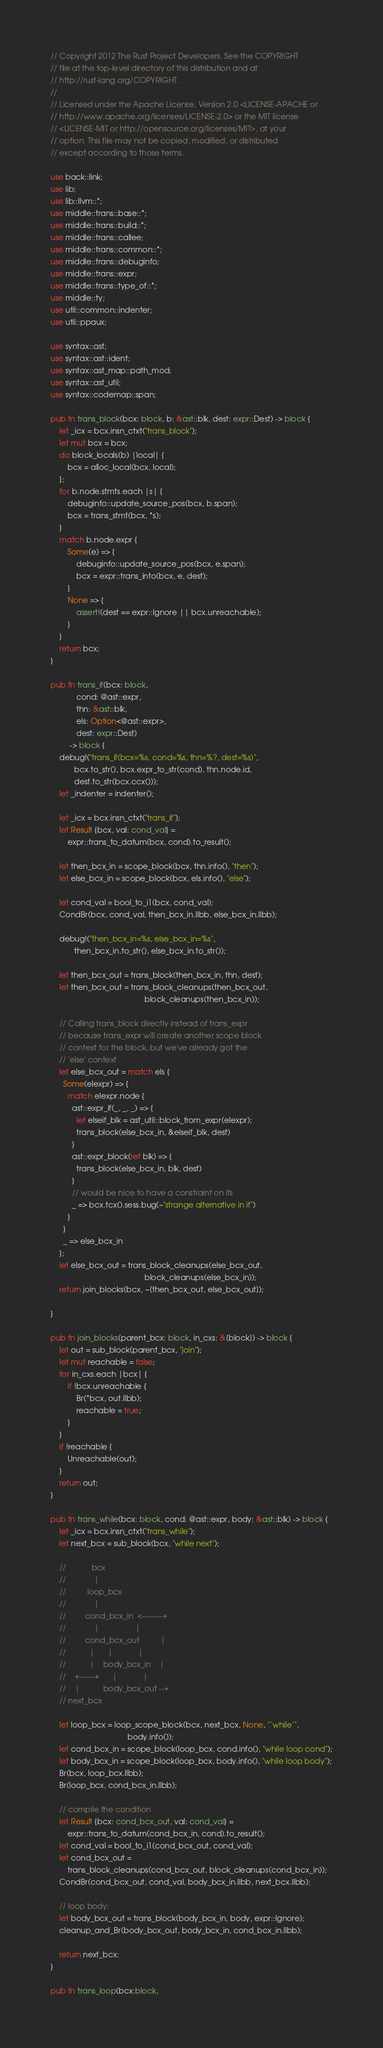<code> <loc_0><loc_0><loc_500><loc_500><_Rust_>// Copyright 2012 The Rust Project Developers. See the COPYRIGHT
// file at the top-level directory of this distribution and at
// http://rust-lang.org/COPYRIGHT.
//
// Licensed under the Apache License, Version 2.0 <LICENSE-APACHE or
// http://www.apache.org/licenses/LICENSE-2.0> or the MIT license
// <LICENSE-MIT or http://opensource.org/licenses/MIT>, at your
// option. This file may not be copied, modified, or distributed
// except according to those terms.

use back::link;
use lib;
use lib::llvm::*;
use middle::trans::base::*;
use middle::trans::build::*;
use middle::trans::callee;
use middle::trans::common::*;
use middle::trans::debuginfo;
use middle::trans::expr;
use middle::trans::type_of::*;
use middle::ty;
use util::common::indenter;
use util::ppaux;

use syntax::ast;
use syntax::ast::ident;
use syntax::ast_map::path_mod;
use syntax::ast_util;
use syntax::codemap::span;

pub fn trans_block(bcx: block, b: &ast::blk, dest: expr::Dest) -> block {
    let _icx = bcx.insn_ctxt("trans_block");
    let mut bcx = bcx;
    do block_locals(b) |local| {
        bcx = alloc_local(bcx, local);
    };
    for b.node.stmts.each |s| {
        debuginfo::update_source_pos(bcx, b.span);
        bcx = trans_stmt(bcx, *s);
    }
    match b.node.expr {
        Some(e) => {
            debuginfo::update_source_pos(bcx, e.span);
            bcx = expr::trans_into(bcx, e, dest);
        }
        None => {
            assert!(dest == expr::Ignore || bcx.unreachable);
        }
    }
    return bcx;
}

pub fn trans_if(bcx: block,
            cond: @ast::expr,
            thn: &ast::blk,
            els: Option<@ast::expr>,
            dest: expr::Dest)
         -> block {
    debug!("trans_if(bcx=%s, cond=%s, thn=%?, dest=%s)",
           bcx.to_str(), bcx.expr_to_str(cond), thn.node.id,
           dest.to_str(bcx.ccx()));
    let _indenter = indenter();

    let _icx = bcx.insn_ctxt("trans_if");
    let Result {bcx, val: cond_val} =
        expr::trans_to_datum(bcx, cond).to_result();

    let then_bcx_in = scope_block(bcx, thn.info(), "then");
    let else_bcx_in = scope_block(bcx, els.info(), "else");

    let cond_val = bool_to_i1(bcx, cond_val);
    CondBr(bcx, cond_val, then_bcx_in.llbb, else_bcx_in.llbb);

    debug!("then_bcx_in=%s, else_bcx_in=%s",
           then_bcx_in.to_str(), else_bcx_in.to_str());

    let then_bcx_out = trans_block(then_bcx_in, thn, dest);
    let then_bcx_out = trans_block_cleanups(then_bcx_out,
                                            block_cleanups(then_bcx_in));

    // Calling trans_block directly instead of trans_expr
    // because trans_expr will create another scope block
    // context for the block, but we've already got the
    // 'else' context
    let else_bcx_out = match els {
      Some(elexpr) => {
        match elexpr.node {
          ast::expr_if(_, _, _) => {
            let elseif_blk = ast_util::block_from_expr(elexpr);
            trans_block(else_bcx_in, &elseif_blk, dest)
          }
          ast::expr_block(ref blk) => {
            trans_block(else_bcx_in, blk, dest)
          }
          // would be nice to have a constraint on ifs
          _ => bcx.tcx().sess.bug(~"strange alternative in if")
        }
      }
      _ => else_bcx_in
    };
    let else_bcx_out = trans_block_cleanups(else_bcx_out,
                                            block_cleanups(else_bcx_in));
    return join_blocks(bcx, ~[then_bcx_out, else_bcx_out]);

}

pub fn join_blocks(parent_bcx: block, in_cxs: &[block]) -> block {
    let out = sub_block(parent_bcx, "join");
    let mut reachable = false;
    for in_cxs.each |bcx| {
        if !bcx.unreachable {
            Br(*bcx, out.llbb);
            reachable = true;
        }
    }
    if !reachable {
        Unreachable(out);
    }
    return out;
}

pub fn trans_while(bcx: block, cond: @ast::expr, body: &ast::blk) -> block {
    let _icx = bcx.insn_ctxt("trans_while");
    let next_bcx = sub_block(bcx, "while next");

    //            bcx
    //             |
    //          loop_bcx
    //             |
    //         cond_bcx_in  <--------+
    //             |                 |
    //         cond_bcx_out          |
    //           |      |            |
    //           |    body_bcx_in    |
    //    +------+      |            |
    //    |           body_bcx_out --+
    // next_bcx

    let loop_bcx = loop_scope_block(bcx, next_bcx, None, "`while`",
                                    body.info());
    let cond_bcx_in = scope_block(loop_bcx, cond.info(), "while loop cond");
    let body_bcx_in = scope_block(loop_bcx, body.info(), "while loop body");
    Br(bcx, loop_bcx.llbb);
    Br(loop_bcx, cond_bcx_in.llbb);

    // compile the condition
    let Result {bcx: cond_bcx_out, val: cond_val} =
        expr::trans_to_datum(cond_bcx_in, cond).to_result();
    let cond_val = bool_to_i1(cond_bcx_out, cond_val);
    let cond_bcx_out =
        trans_block_cleanups(cond_bcx_out, block_cleanups(cond_bcx_in));
    CondBr(cond_bcx_out, cond_val, body_bcx_in.llbb, next_bcx.llbb);

    // loop body:
    let body_bcx_out = trans_block(body_bcx_in, body, expr::Ignore);
    cleanup_and_Br(body_bcx_out, body_bcx_in, cond_bcx_in.llbb);

    return next_bcx;
}

pub fn trans_loop(bcx:block,</code> 